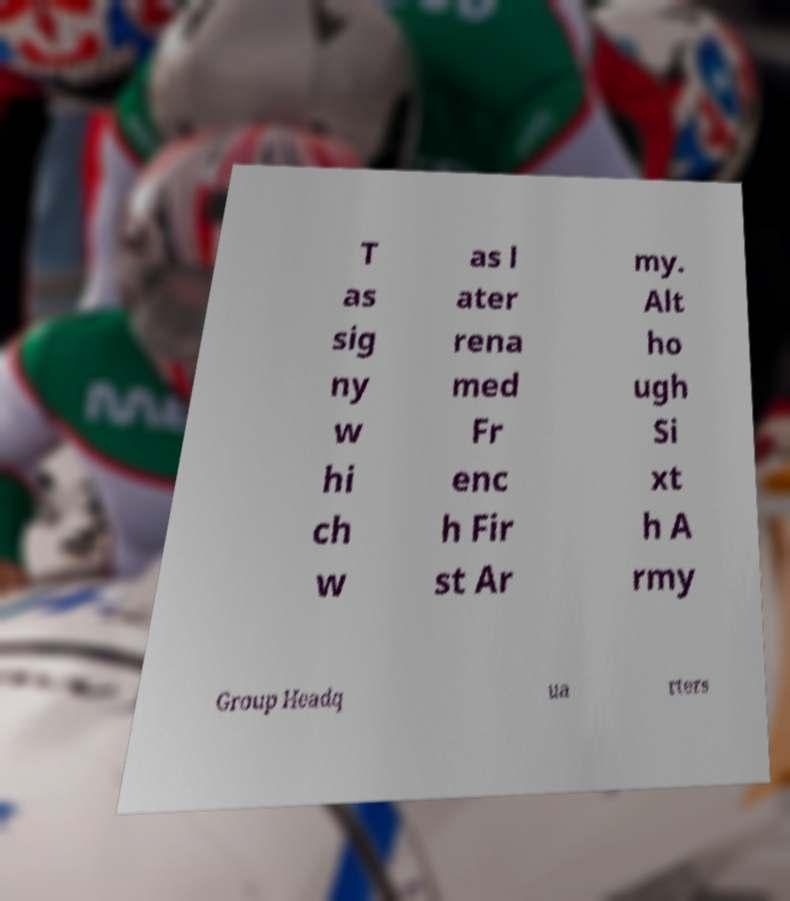I need the written content from this picture converted into text. Can you do that? T as sig ny w hi ch w as l ater rena med Fr enc h Fir st Ar my. Alt ho ugh Si xt h A rmy Group Headq ua rters 